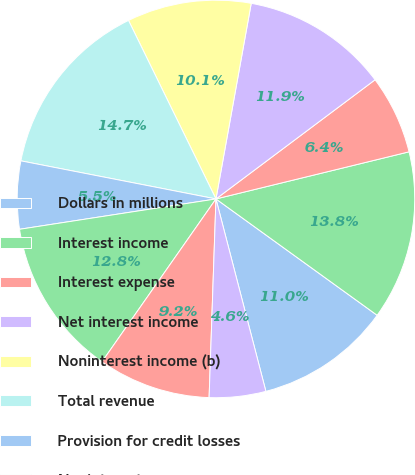<chart> <loc_0><loc_0><loc_500><loc_500><pie_chart><fcel>Dollars in millions<fcel>Interest income<fcel>Interest expense<fcel>Net interest income<fcel>Noninterest income (b)<fcel>Total revenue<fcel>Provision for credit losses<fcel>Noninterest expense<fcel>Income before income taxes and<fcel>Income taxes<nl><fcel>11.01%<fcel>13.76%<fcel>6.42%<fcel>11.93%<fcel>10.09%<fcel>14.68%<fcel>5.51%<fcel>12.84%<fcel>9.17%<fcel>4.59%<nl></chart> 